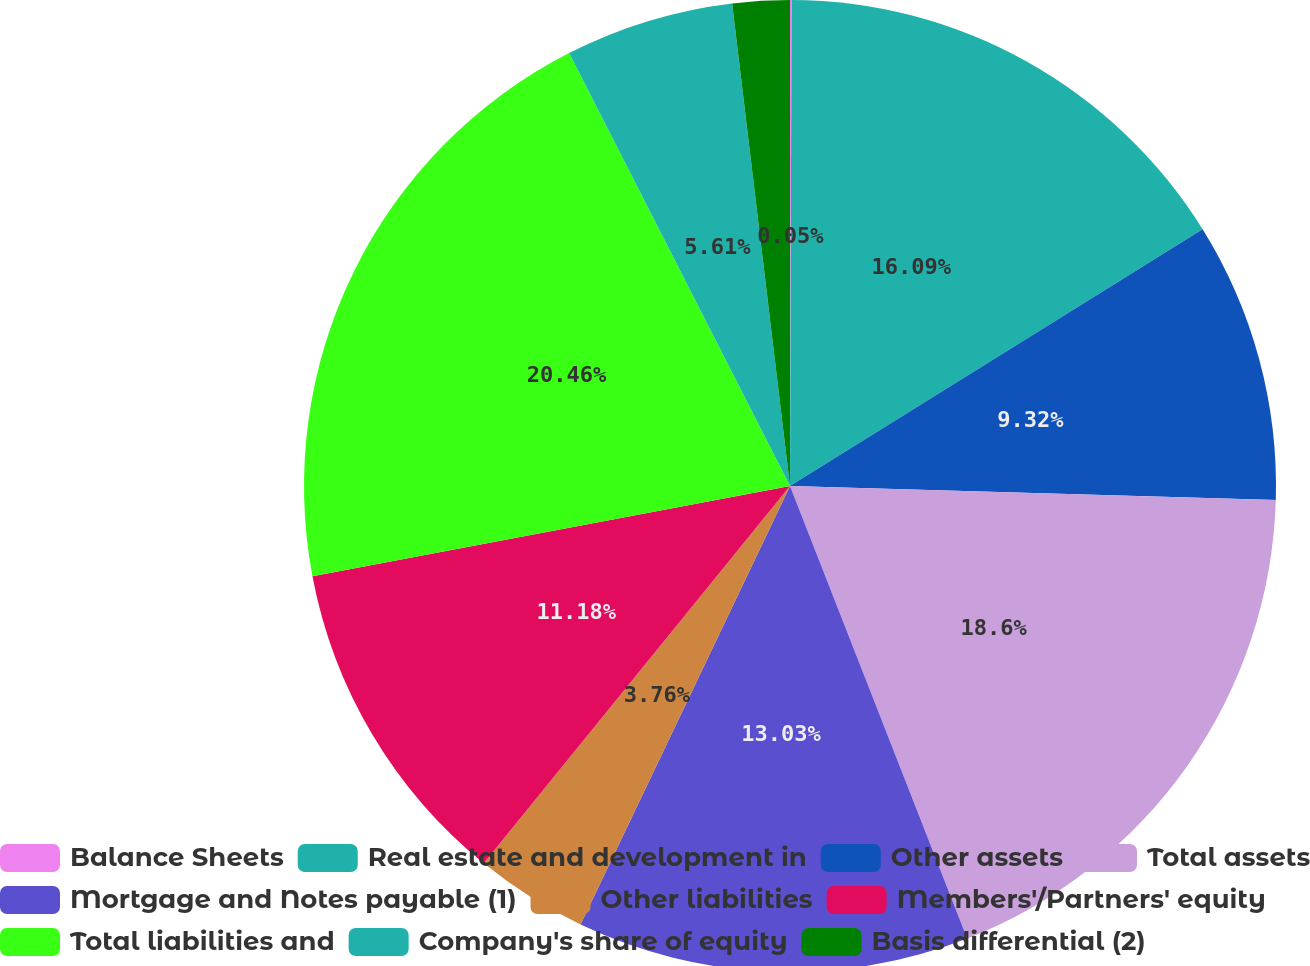<chart> <loc_0><loc_0><loc_500><loc_500><pie_chart><fcel>Balance Sheets<fcel>Real estate and development in<fcel>Other assets<fcel>Total assets<fcel>Mortgage and Notes payable (1)<fcel>Other liabilities<fcel>Members'/Partners' equity<fcel>Total liabilities and<fcel>Company's share of equity<fcel>Basis differential (2)<nl><fcel>0.05%<fcel>16.09%<fcel>9.32%<fcel>18.6%<fcel>13.03%<fcel>3.76%<fcel>11.18%<fcel>20.46%<fcel>5.61%<fcel>1.9%<nl></chart> 